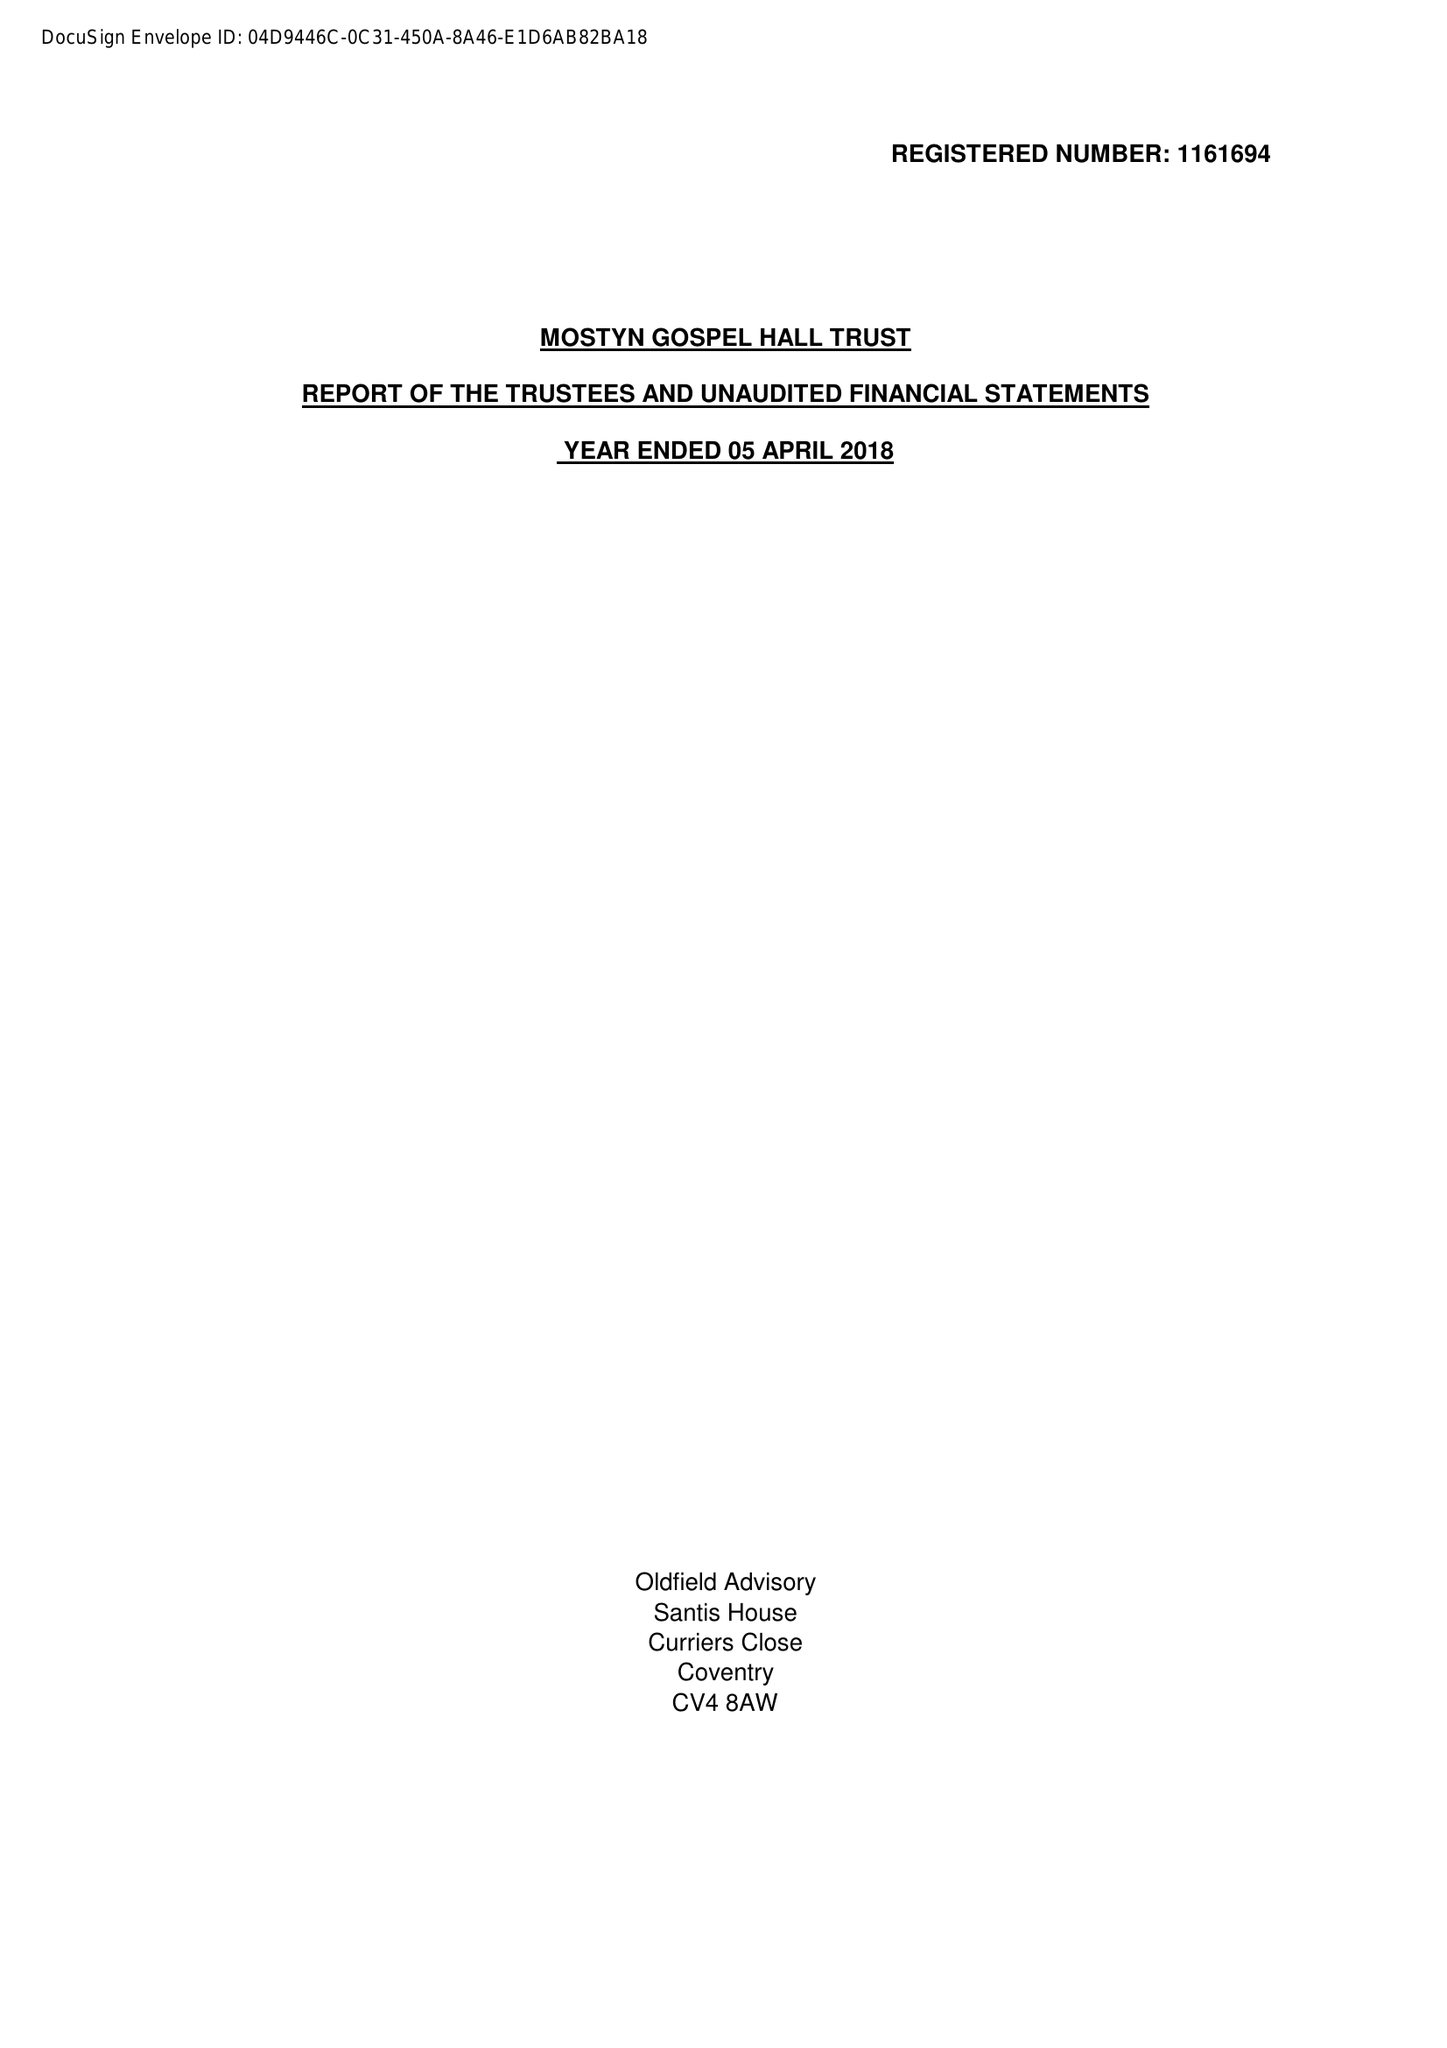What is the value for the address__postcode?
Answer the question using a single word or phrase. LE6 0JP 